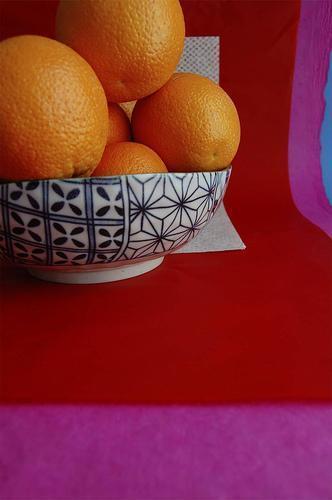How many oranges are in the bowl?
Give a very brief answer. 5. How many oranges are there?
Give a very brief answer. 2. 